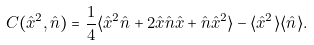Convert formula to latex. <formula><loc_0><loc_0><loc_500><loc_500>C ( \hat { x } ^ { 2 } , \hat { n } ) = \frac { 1 } { 4 } \langle \hat { x } ^ { 2 } \hat { n } + 2 \hat { x } \hat { n } \hat { x } + \hat { n } \hat { x } ^ { 2 } \rangle - \langle \hat { x } ^ { 2 } \rangle \langle \hat { n } \rangle .</formula> 